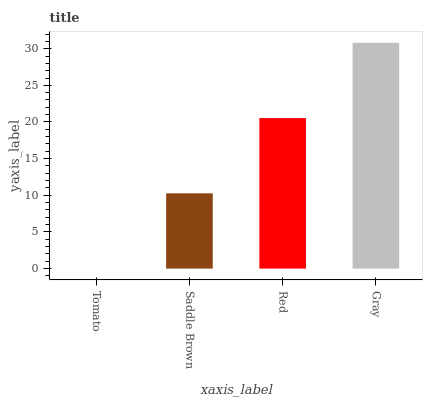Is Tomato the minimum?
Answer yes or no. Yes. Is Gray the maximum?
Answer yes or no. Yes. Is Saddle Brown the minimum?
Answer yes or no. No. Is Saddle Brown the maximum?
Answer yes or no. No. Is Saddle Brown greater than Tomato?
Answer yes or no. Yes. Is Tomato less than Saddle Brown?
Answer yes or no. Yes. Is Tomato greater than Saddle Brown?
Answer yes or no. No. Is Saddle Brown less than Tomato?
Answer yes or no. No. Is Red the high median?
Answer yes or no. Yes. Is Saddle Brown the low median?
Answer yes or no. Yes. Is Saddle Brown the high median?
Answer yes or no. No. Is Tomato the low median?
Answer yes or no. No. 